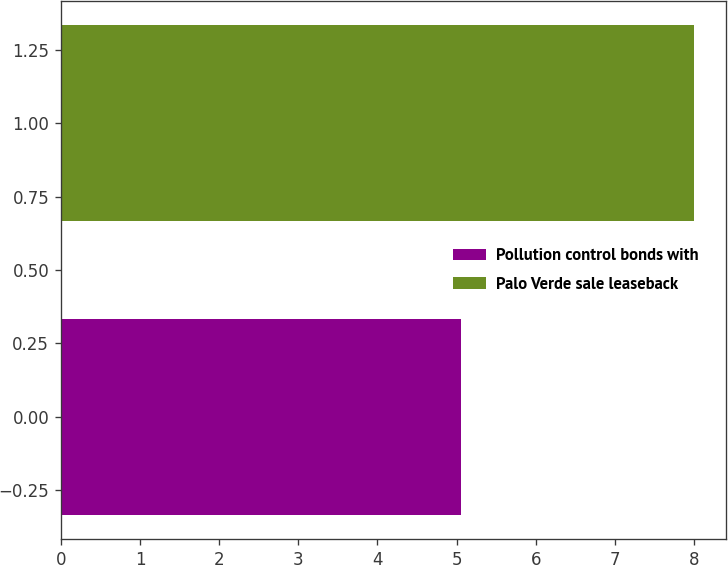Convert chart to OTSL. <chart><loc_0><loc_0><loc_500><loc_500><bar_chart><fcel>Pollution control bonds with<fcel>Palo Verde sale leaseback<nl><fcel>5.05<fcel>8<nl></chart> 